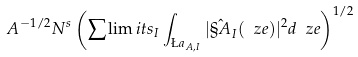<formula> <loc_0><loc_0><loc_500><loc_500>A ^ { - 1 / 2 } N ^ { s } \left ( \sum \lim i t s _ { I } \int _ { \L a _ { A , I } } | \hat { \S A } _ { I } ( \ z e ) | ^ { 2 } d \ z e \right ) ^ { 1 / 2 }</formula> 